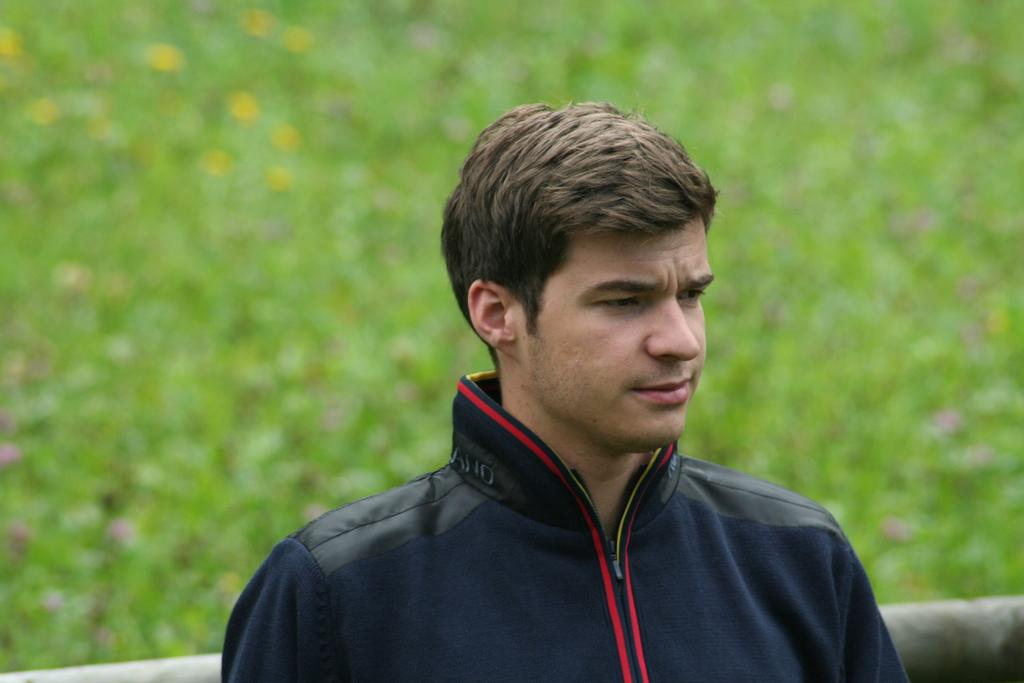What is the main subject of the image? The main subject of the image is a man. What is the man wearing in the image? The man is wearing a jacket. What type of environment is visible in the image? There is grass in the image. How is the background of the image depicted? The background is blurred. What type of machine can be seen in the background of the image? There is no machine present in the background of the image. Who is the man's friend in the image? There is no friend visible in the image. 